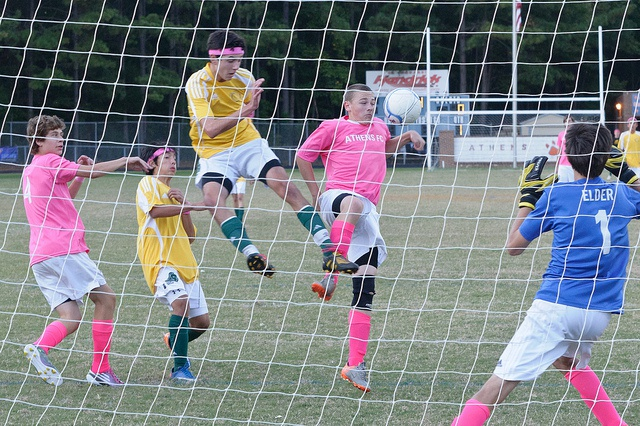Describe the objects in this image and their specific colors. I can see people in black, lavender, blue, and darkgray tones, people in black, darkgray, violet, and lavender tones, people in black, violet, lavender, and darkgray tones, people in black, darkgray, lavender, and gray tones, and people in black, lavender, tan, khaki, and darkgray tones in this image. 